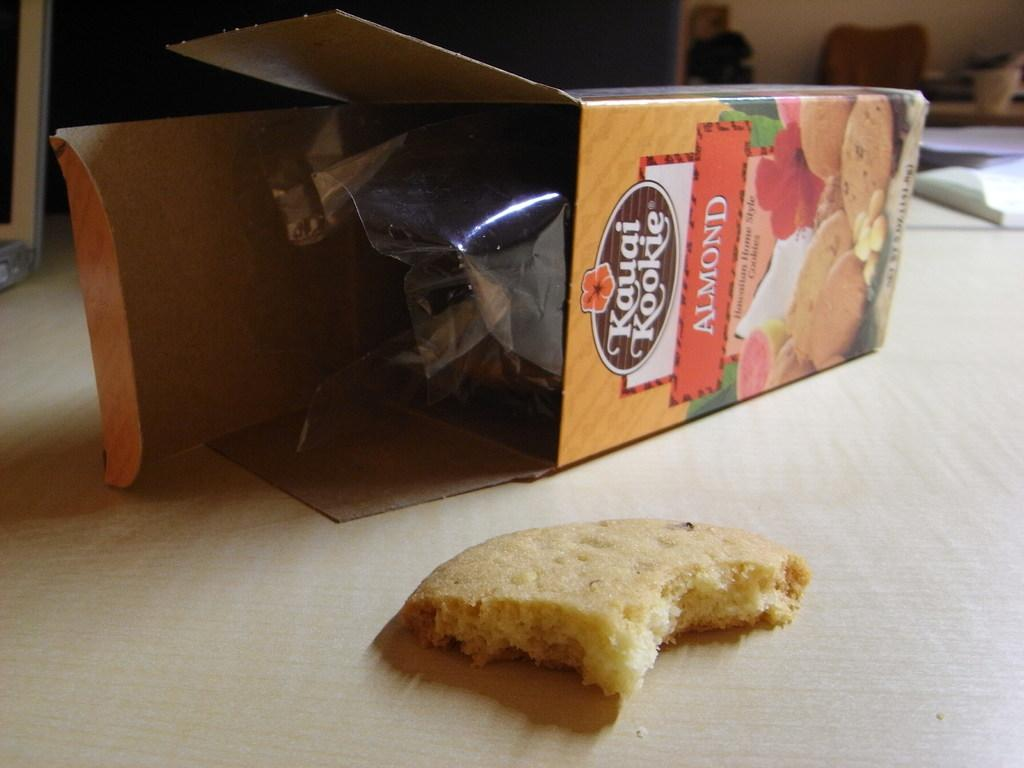What is inside the container that is visible in the image? The carton contains almond cookies. Where is the carton located in the image? The carton is placed on a table. What is the title of the story depicted in the image? There is no story depicted in the image, as it only features a carton of almond cookies placed on a table. 